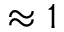<formula> <loc_0><loc_0><loc_500><loc_500>\approx 1</formula> 